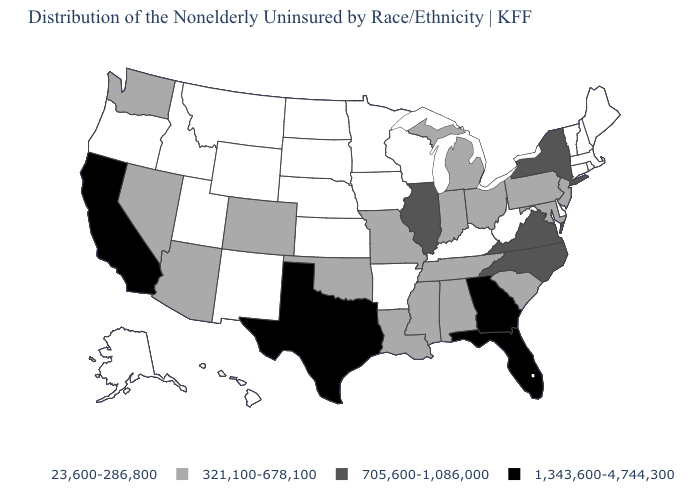What is the value of Louisiana?
Short answer required. 321,100-678,100. Name the states that have a value in the range 705,600-1,086,000?
Short answer required. Illinois, New York, North Carolina, Virginia. What is the value of Massachusetts?
Answer briefly. 23,600-286,800. What is the value of Kentucky?
Write a very short answer. 23,600-286,800. Does Tennessee have a lower value than Georgia?
Be succinct. Yes. Among the states that border Texas , which have the highest value?
Answer briefly. Louisiana, Oklahoma. Among the states that border Idaho , does Washington have the highest value?
Answer briefly. Yes. What is the value of New Hampshire?
Write a very short answer. 23,600-286,800. What is the value of Delaware?
Write a very short answer. 23,600-286,800. What is the value of Missouri?
Write a very short answer. 321,100-678,100. Does Nebraska have a lower value than Maryland?
Write a very short answer. Yes. Which states hav the highest value in the Northeast?
Be succinct. New York. Name the states that have a value in the range 705,600-1,086,000?
Keep it brief. Illinois, New York, North Carolina, Virginia. How many symbols are there in the legend?
Give a very brief answer. 4. Does Wyoming have a lower value than Vermont?
Give a very brief answer. No. 